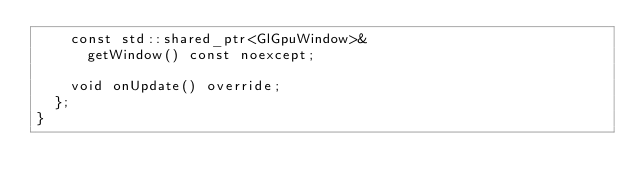<code> <loc_0><loc_0><loc_500><loc_500><_C++_>		const std::shared_ptr<GlGpuWindow>&
			getWindow() const noexcept;

		void onUpdate() override;
	};
}
</code> 